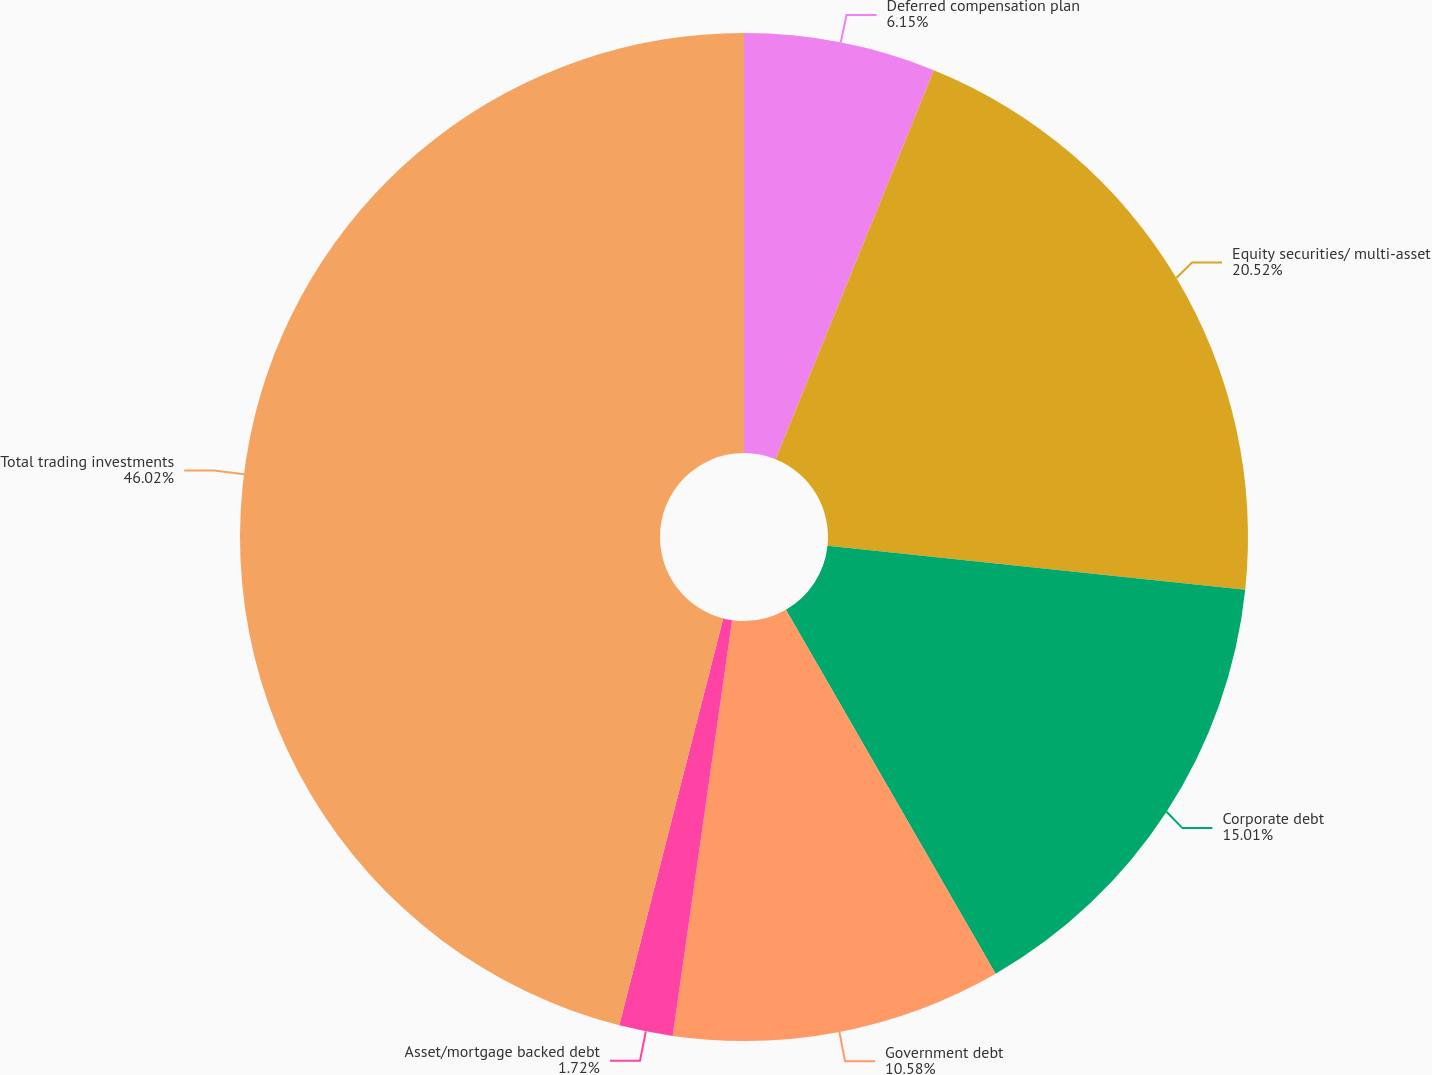<chart> <loc_0><loc_0><loc_500><loc_500><pie_chart><fcel>Deferred compensation plan<fcel>Equity securities/ multi-asset<fcel>Corporate debt<fcel>Government debt<fcel>Asset/mortgage backed debt<fcel>Total trading investments<nl><fcel>6.15%<fcel>20.52%<fcel>15.01%<fcel>10.58%<fcel>1.72%<fcel>46.02%<nl></chart> 